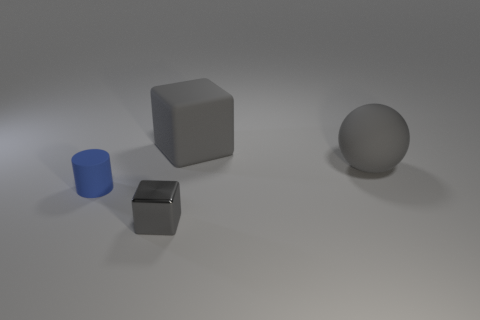Is the small gray thing made of the same material as the gray cube that is behind the blue matte thing?
Provide a short and direct response. No. Is there anything else that has the same material as the tiny gray object?
Ensure brevity in your answer.  No. Is the cube behind the blue rubber thing made of the same material as the large gray object to the right of the large gray cube?
Keep it short and to the point. Yes. The tiny object in front of the thing that is to the left of the gray cube in front of the big rubber block is what color?
Provide a short and direct response. Gray. What number of other things are there of the same shape as the blue object?
Your answer should be compact. 0. Does the large cube have the same color as the sphere?
Offer a terse response. Yes. How many objects are gray rubber balls or rubber objects that are behind the tiny matte object?
Your answer should be compact. 2. Are there any gray rubber things that have the same size as the cylinder?
Keep it short and to the point. No. Do the large block and the big ball have the same material?
Provide a succinct answer. Yes. What number of objects are small cylinders or tiny metal cubes?
Your answer should be very brief. 2. 